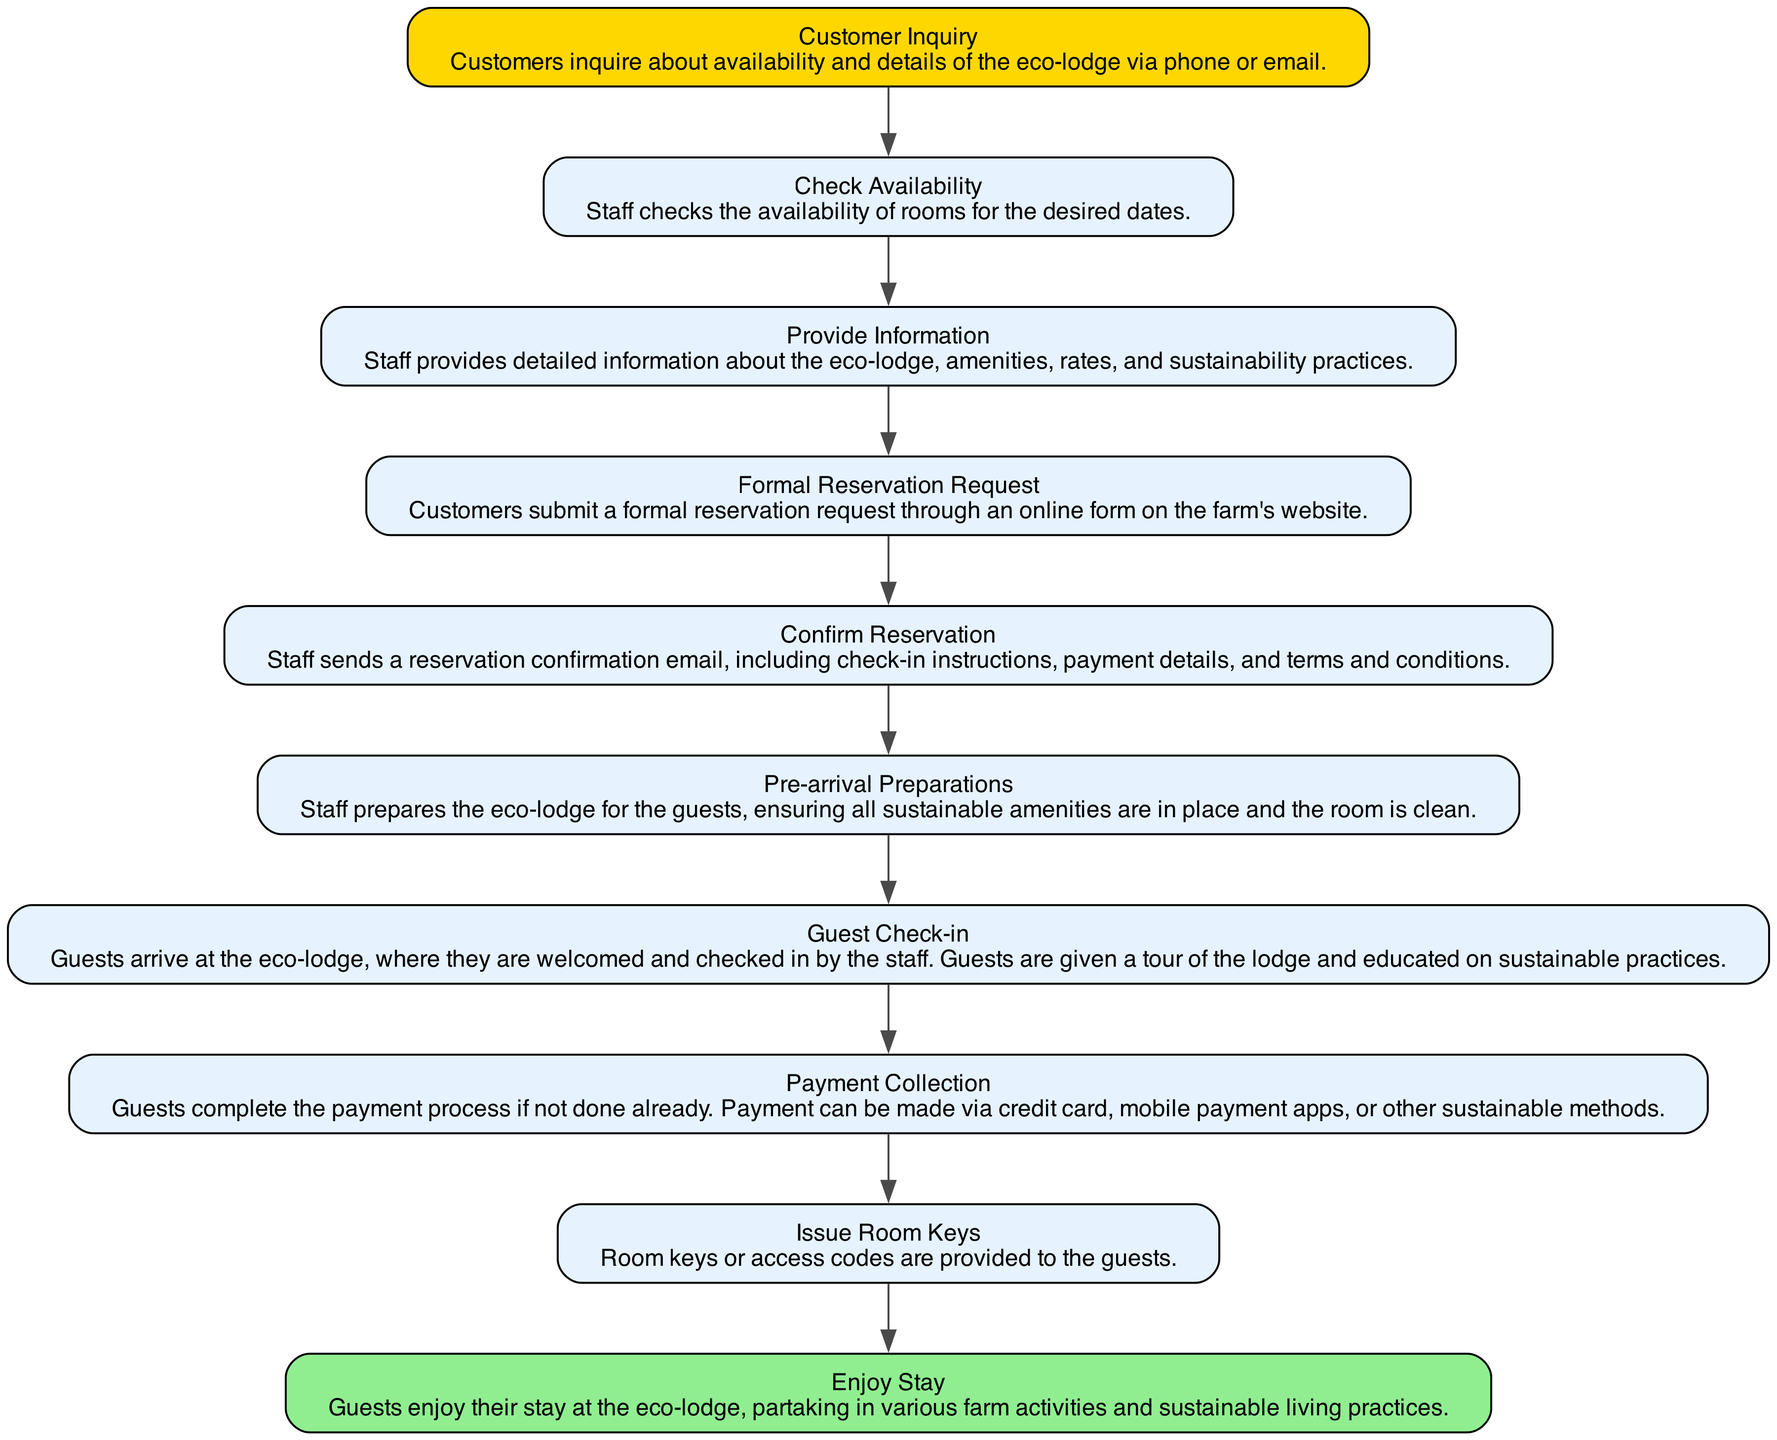What is the first step in the guest reservation process? The diagram indicates that the first step is "Customer Inquiry," where customers inquire about availability and details of the eco-lodge.
Answer: Customer Inquiry How many nodes are there in the diagram? By counting all distinct steps described in the diagram, there are a total of 10 nodes representing various stages in the guest reservation and check-in process.
Answer: 10 What comes after "Formal Reservation Request"? Following "Formal Reservation Request," the next step indicated in the diagram is "Confirm Reservation," illustrating the sequential flow of the process.
Answer: Confirm Reservation What is the last step in the process? The diagram shows that the final step for guests is "Enjoy Stay," indicating the completion of their check-in process and the beginning of their experience at the eco-lodge.
Answer: Enjoy Stay Which step involves payment collection? The step labeled "Payment Collection" specifically refers to the process where guests complete their payment, highlighting its significance in the reservation process.
Answer: Payment Collection What must customers do after receiving confirmation? According to the diagram, after receiving "Confirm Reservation," customers move to "Pre-arrival Preparations," indicating that staff gets ready for the guests’ arrival after confirming the reservation.
Answer: Pre-arrival Preparations How does the guest receive room keys? The diagram shows that "Issue Room Keys" follows the "Guest Check-in" step, meaning that guests will receive their keys after checking in at the eco-lodge.
Answer: Issue Room Keys What action directly follows the "Check Availability"? The immediate action that follows "Check Availability" is "Provide Information," demonstrating the continuous flow of staff responsibilities in the reservation process.
Answer: Provide Information What is provided during the "Guest Check-in"? During the "Guest Check-in," guests are welcomed and given a tour of the lodge, along with education on sustainable practices, emphasizing the eco-lodge's commitment to sustainability.
Answer: Tour and education on sustainable practices 